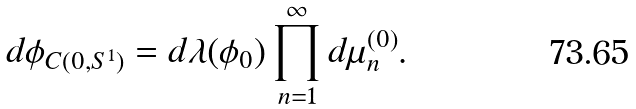Convert formula to latex. <formula><loc_0><loc_0><loc_500><loc_500>d \phi _ { C ( 0 , S ^ { 1 } ) } = d \lambda ( \phi _ { 0 } ) \prod _ { n = 1 } ^ { \infty } d \mu _ { n } ^ { ( 0 ) } .</formula> 